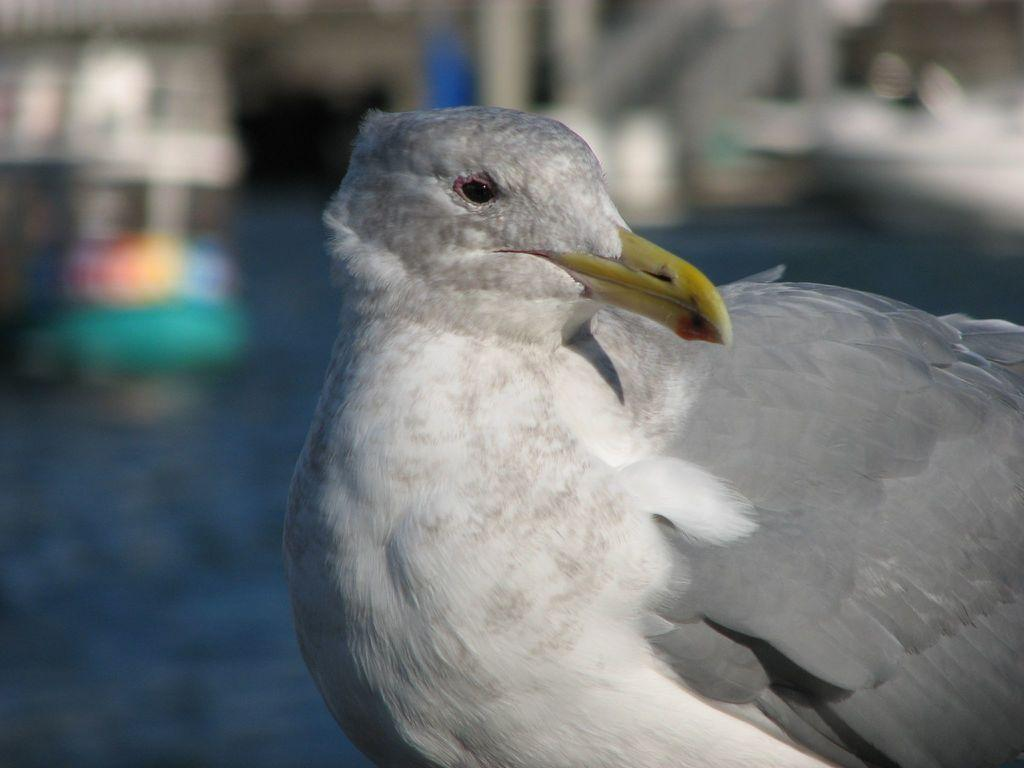What type of bird is in the image? There is a pigeon in the image. Where is the pigeon located in the image? The pigeon is in the middle of the image. What color is the pigeon? The color of the pigeon is white. What type of list can be seen in the image? There is no list present in the image; it features a white pigeon in the middle. 